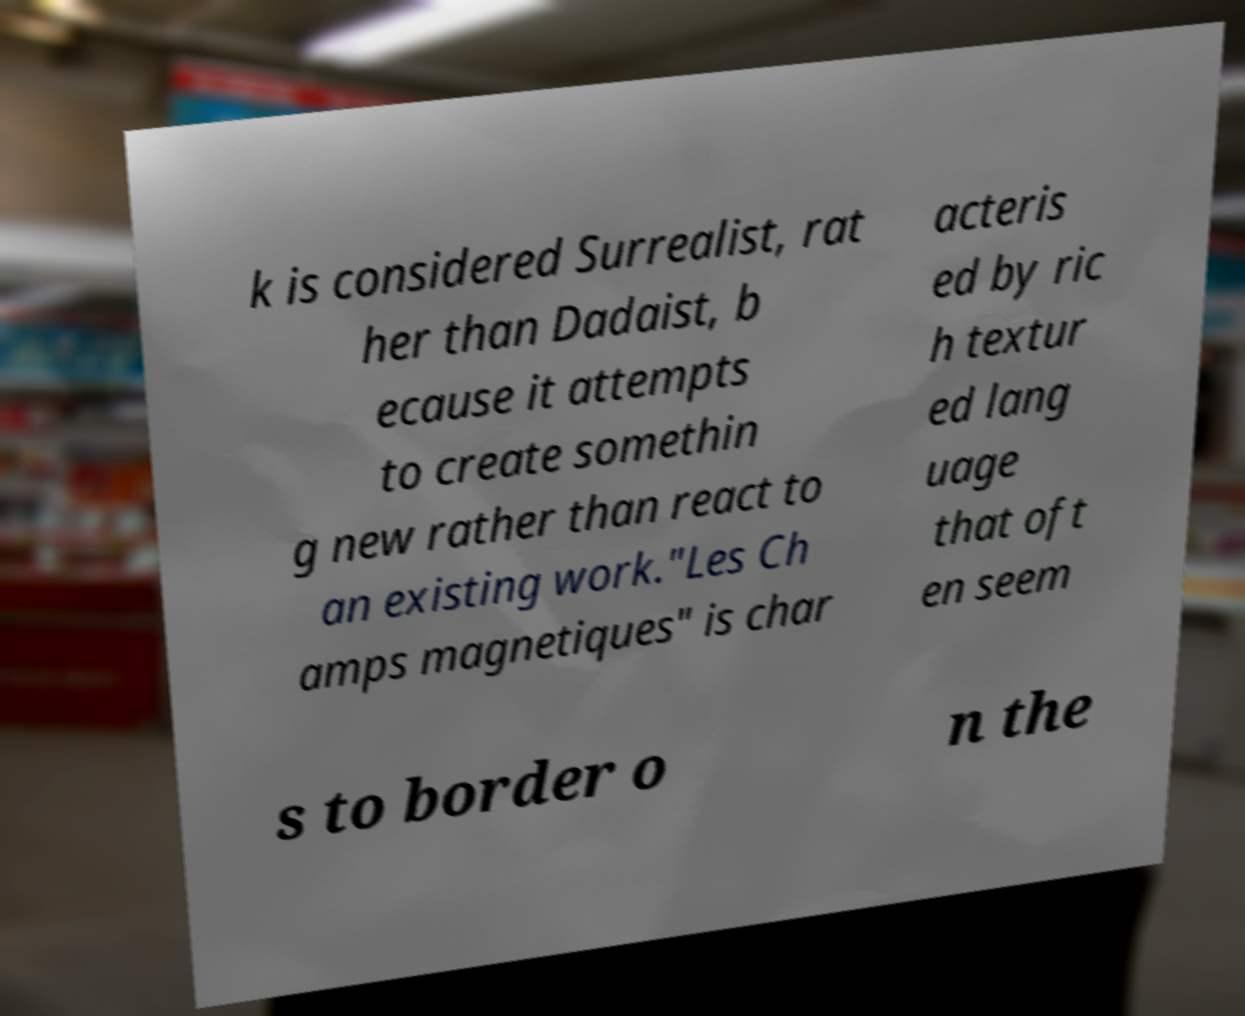There's text embedded in this image that I need extracted. Can you transcribe it verbatim? k is considered Surrealist, rat her than Dadaist, b ecause it attempts to create somethin g new rather than react to an existing work."Les Ch amps magnetiques" is char acteris ed by ric h textur ed lang uage that oft en seem s to border o n the 